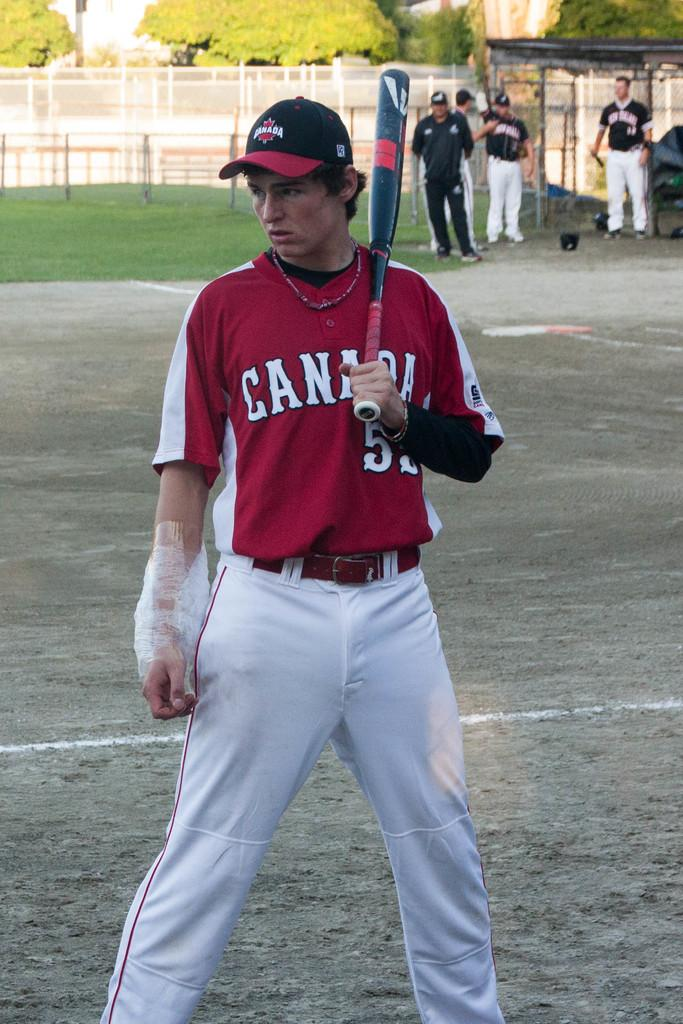<image>
Describe the image concisely. A man holding a baseball bat with the word Canada on his shirt. 